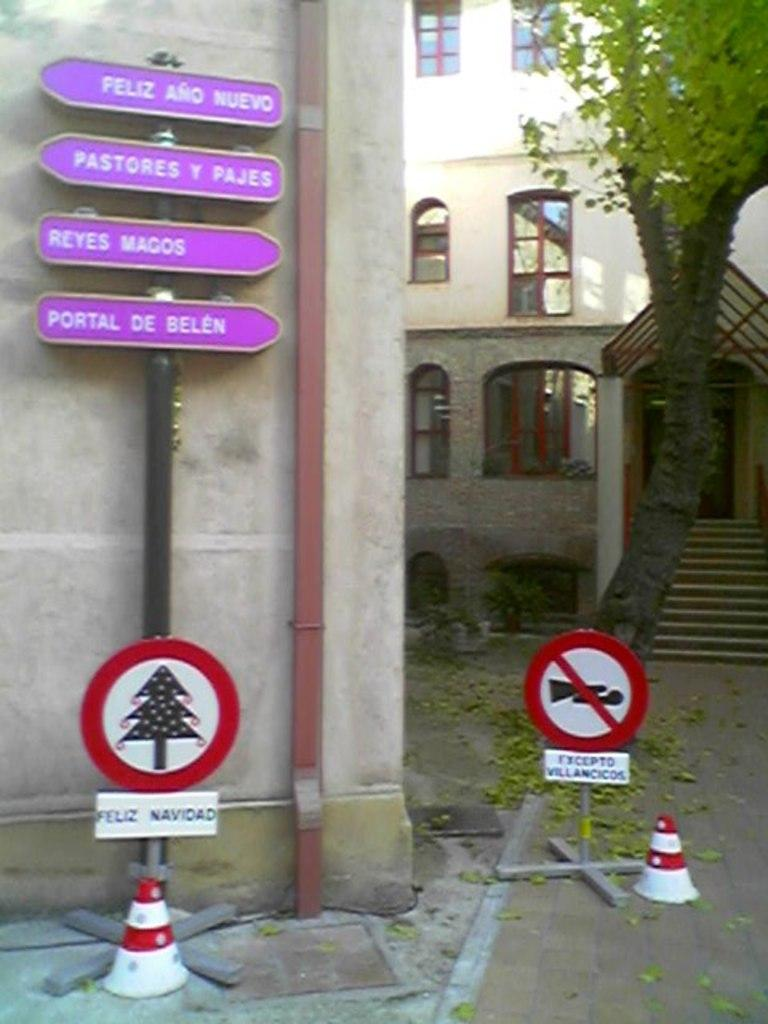<image>
Summarize the visual content of the image. A cluster of signage that shows directions, the bottom of which says feliz navidad. 